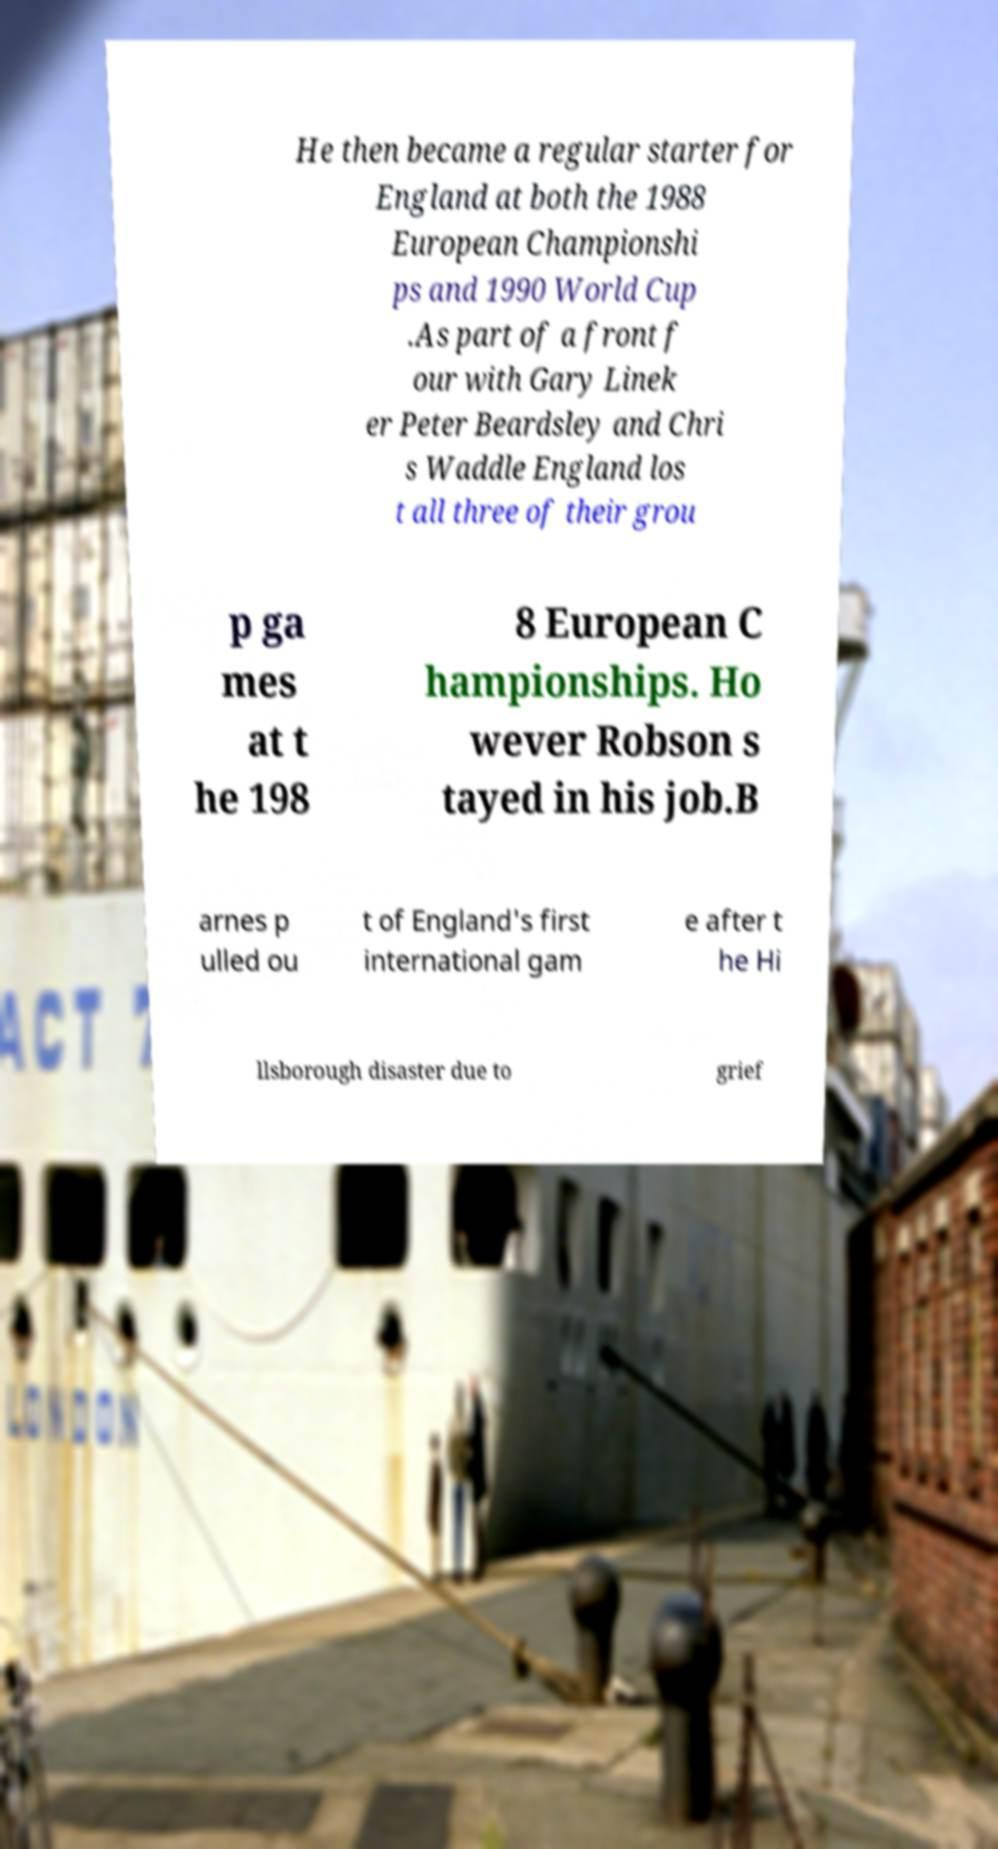What messages or text are displayed in this image? I need them in a readable, typed format. He then became a regular starter for England at both the 1988 European Championshi ps and 1990 World Cup .As part of a front f our with Gary Linek er Peter Beardsley and Chri s Waddle England los t all three of their grou p ga mes at t he 198 8 European C hampionships. Ho wever Robson s tayed in his job.B arnes p ulled ou t of England's first international gam e after t he Hi llsborough disaster due to grief 